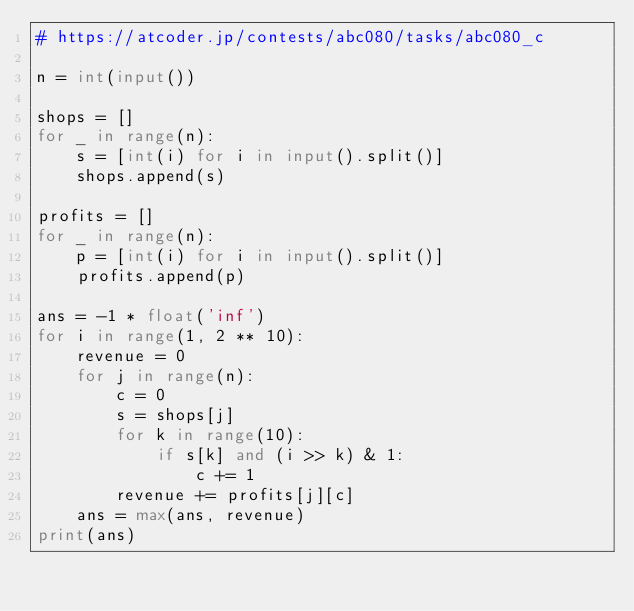Convert code to text. <code><loc_0><loc_0><loc_500><loc_500><_Python_># https://atcoder.jp/contests/abc080/tasks/abc080_c

n = int(input())

shops = []
for _ in range(n):
    s = [int(i) for i in input().split()]
    shops.append(s)

profits = []
for _ in range(n):
    p = [int(i) for i in input().split()]
    profits.append(p)

ans = -1 * float('inf')
for i in range(1, 2 ** 10):
    revenue = 0
    for j in range(n):
        c = 0
        s = shops[j]
        for k in range(10):
            if s[k] and (i >> k) & 1:
                c += 1
        revenue += profits[j][c]
    ans = max(ans, revenue)
print(ans)</code> 